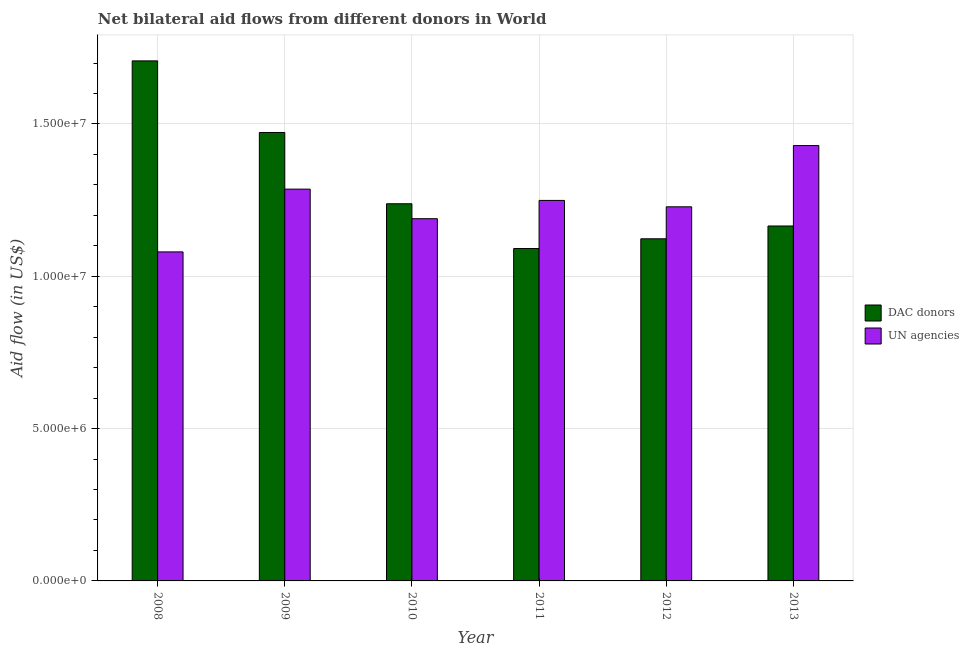How many groups of bars are there?
Offer a terse response. 6. Are the number of bars per tick equal to the number of legend labels?
Make the answer very short. Yes. Are the number of bars on each tick of the X-axis equal?
Offer a terse response. Yes. How many bars are there on the 5th tick from the left?
Offer a very short reply. 2. What is the label of the 3rd group of bars from the left?
Your answer should be very brief. 2010. In how many cases, is the number of bars for a given year not equal to the number of legend labels?
Ensure brevity in your answer.  0. What is the aid flow from dac donors in 2010?
Keep it short and to the point. 1.24e+07. Across all years, what is the maximum aid flow from un agencies?
Keep it short and to the point. 1.43e+07. Across all years, what is the minimum aid flow from un agencies?
Provide a succinct answer. 1.08e+07. What is the total aid flow from dac donors in the graph?
Make the answer very short. 7.80e+07. What is the difference between the aid flow from un agencies in 2009 and that in 2012?
Your response must be concise. 5.80e+05. What is the difference between the aid flow from dac donors in 2011 and the aid flow from un agencies in 2009?
Your answer should be compact. -3.81e+06. What is the average aid flow from dac donors per year?
Your response must be concise. 1.30e+07. What is the ratio of the aid flow from un agencies in 2009 to that in 2013?
Your response must be concise. 0.9. Is the aid flow from dac donors in 2009 less than that in 2012?
Your answer should be compact. No. Is the difference between the aid flow from un agencies in 2008 and 2013 greater than the difference between the aid flow from dac donors in 2008 and 2013?
Provide a succinct answer. No. What is the difference between the highest and the second highest aid flow from dac donors?
Give a very brief answer. 2.35e+06. What is the difference between the highest and the lowest aid flow from dac donors?
Your answer should be very brief. 6.16e+06. In how many years, is the aid flow from un agencies greater than the average aid flow from un agencies taken over all years?
Provide a short and direct response. 3. What does the 2nd bar from the left in 2009 represents?
Offer a very short reply. UN agencies. What does the 2nd bar from the right in 2010 represents?
Offer a terse response. DAC donors. Are all the bars in the graph horizontal?
Provide a succinct answer. No. What is the difference between two consecutive major ticks on the Y-axis?
Your response must be concise. 5.00e+06. Are the values on the major ticks of Y-axis written in scientific E-notation?
Provide a succinct answer. Yes. Does the graph contain grids?
Ensure brevity in your answer.  Yes. Where does the legend appear in the graph?
Offer a very short reply. Center right. What is the title of the graph?
Give a very brief answer. Net bilateral aid flows from different donors in World. What is the label or title of the Y-axis?
Offer a very short reply. Aid flow (in US$). What is the Aid flow (in US$) of DAC donors in 2008?
Make the answer very short. 1.71e+07. What is the Aid flow (in US$) of UN agencies in 2008?
Offer a very short reply. 1.08e+07. What is the Aid flow (in US$) in DAC donors in 2009?
Make the answer very short. 1.47e+07. What is the Aid flow (in US$) in UN agencies in 2009?
Offer a terse response. 1.29e+07. What is the Aid flow (in US$) of DAC donors in 2010?
Ensure brevity in your answer.  1.24e+07. What is the Aid flow (in US$) in UN agencies in 2010?
Provide a succinct answer. 1.19e+07. What is the Aid flow (in US$) of DAC donors in 2011?
Your response must be concise. 1.09e+07. What is the Aid flow (in US$) of UN agencies in 2011?
Your answer should be very brief. 1.25e+07. What is the Aid flow (in US$) of DAC donors in 2012?
Give a very brief answer. 1.12e+07. What is the Aid flow (in US$) of UN agencies in 2012?
Make the answer very short. 1.23e+07. What is the Aid flow (in US$) in DAC donors in 2013?
Your response must be concise. 1.16e+07. What is the Aid flow (in US$) of UN agencies in 2013?
Offer a terse response. 1.43e+07. Across all years, what is the maximum Aid flow (in US$) of DAC donors?
Give a very brief answer. 1.71e+07. Across all years, what is the maximum Aid flow (in US$) of UN agencies?
Ensure brevity in your answer.  1.43e+07. Across all years, what is the minimum Aid flow (in US$) of DAC donors?
Your answer should be compact. 1.09e+07. Across all years, what is the minimum Aid flow (in US$) in UN agencies?
Keep it short and to the point. 1.08e+07. What is the total Aid flow (in US$) in DAC donors in the graph?
Offer a terse response. 7.80e+07. What is the total Aid flow (in US$) in UN agencies in the graph?
Provide a succinct answer. 7.46e+07. What is the difference between the Aid flow (in US$) of DAC donors in 2008 and that in 2009?
Ensure brevity in your answer.  2.35e+06. What is the difference between the Aid flow (in US$) of UN agencies in 2008 and that in 2009?
Provide a succinct answer. -2.06e+06. What is the difference between the Aid flow (in US$) in DAC donors in 2008 and that in 2010?
Your answer should be compact. 4.69e+06. What is the difference between the Aid flow (in US$) in UN agencies in 2008 and that in 2010?
Keep it short and to the point. -1.09e+06. What is the difference between the Aid flow (in US$) of DAC donors in 2008 and that in 2011?
Make the answer very short. 6.16e+06. What is the difference between the Aid flow (in US$) in UN agencies in 2008 and that in 2011?
Provide a short and direct response. -1.69e+06. What is the difference between the Aid flow (in US$) in DAC donors in 2008 and that in 2012?
Provide a short and direct response. 5.84e+06. What is the difference between the Aid flow (in US$) of UN agencies in 2008 and that in 2012?
Your answer should be very brief. -1.48e+06. What is the difference between the Aid flow (in US$) of DAC donors in 2008 and that in 2013?
Provide a short and direct response. 5.42e+06. What is the difference between the Aid flow (in US$) of UN agencies in 2008 and that in 2013?
Offer a terse response. -3.49e+06. What is the difference between the Aid flow (in US$) in DAC donors in 2009 and that in 2010?
Your answer should be very brief. 2.34e+06. What is the difference between the Aid flow (in US$) of UN agencies in 2009 and that in 2010?
Make the answer very short. 9.70e+05. What is the difference between the Aid flow (in US$) in DAC donors in 2009 and that in 2011?
Keep it short and to the point. 3.81e+06. What is the difference between the Aid flow (in US$) in UN agencies in 2009 and that in 2011?
Your response must be concise. 3.70e+05. What is the difference between the Aid flow (in US$) in DAC donors in 2009 and that in 2012?
Ensure brevity in your answer.  3.49e+06. What is the difference between the Aid flow (in US$) in UN agencies in 2009 and that in 2012?
Offer a terse response. 5.80e+05. What is the difference between the Aid flow (in US$) in DAC donors in 2009 and that in 2013?
Offer a very short reply. 3.07e+06. What is the difference between the Aid flow (in US$) of UN agencies in 2009 and that in 2013?
Your answer should be very brief. -1.43e+06. What is the difference between the Aid flow (in US$) in DAC donors in 2010 and that in 2011?
Your answer should be very brief. 1.47e+06. What is the difference between the Aid flow (in US$) of UN agencies in 2010 and that in 2011?
Offer a very short reply. -6.00e+05. What is the difference between the Aid flow (in US$) in DAC donors in 2010 and that in 2012?
Your response must be concise. 1.15e+06. What is the difference between the Aid flow (in US$) of UN agencies in 2010 and that in 2012?
Your response must be concise. -3.90e+05. What is the difference between the Aid flow (in US$) in DAC donors in 2010 and that in 2013?
Make the answer very short. 7.30e+05. What is the difference between the Aid flow (in US$) in UN agencies in 2010 and that in 2013?
Your response must be concise. -2.40e+06. What is the difference between the Aid flow (in US$) of DAC donors in 2011 and that in 2012?
Provide a succinct answer. -3.20e+05. What is the difference between the Aid flow (in US$) of UN agencies in 2011 and that in 2012?
Offer a terse response. 2.10e+05. What is the difference between the Aid flow (in US$) in DAC donors in 2011 and that in 2013?
Make the answer very short. -7.40e+05. What is the difference between the Aid flow (in US$) in UN agencies in 2011 and that in 2013?
Your answer should be very brief. -1.80e+06. What is the difference between the Aid flow (in US$) in DAC donors in 2012 and that in 2013?
Your answer should be compact. -4.20e+05. What is the difference between the Aid flow (in US$) of UN agencies in 2012 and that in 2013?
Make the answer very short. -2.01e+06. What is the difference between the Aid flow (in US$) in DAC donors in 2008 and the Aid flow (in US$) in UN agencies in 2009?
Provide a short and direct response. 4.21e+06. What is the difference between the Aid flow (in US$) in DAC donors in 2008 and the Aid flow (in US$) in UN agencies in 2010?
Make the answer very short. 5.18e+06. What is the difference between the Aid flow (in US$) of DAC donors in 2008 and the Aid flow (in US$) of UN agencies in 2011?
Keep it short and to the point. 4.58e+06. What is the difference between the Aid flow (in US$) of DAC donors in 2008 and the Aid flow (in US$) of UN agencies in 2012?
Provide a succinct answer. 4.79e+06. What is the difference between the Aid flow (in US$) in DAC donors in 2008 and the Aid flow (in US$) in UN agencies in 2013?
Your answer should be compact. 2.78e+06. What is the difference between the Aid flow (in US$) of DAC donors in 2009 and the Aid flow (in US$) of UN agencies in 2010?
Ensure brevity in your answer.  2.83e+06. What is the difference between the Aid flow (in US$) in DAC donors in 2009 and the Aid flow (in US$) in UN agencies in 2011?
Your answer should be compact. 2.23e+06. What is the difference between the Aid flow (in US$) of DAC donors in 2009 and the Aid flow (in US$) of UN agencies in 2012?
Your response must be concise. 2.44e+06. What is the difference between the Aid flow (in US$) in DAC donors in 2009 and the Aid flow (in US$) in UN agencies in 2013?
Keep it short and to the point. 4.30e+05. What is the difference between the Aid flow (in US$) of DAC donors in 2010 and the Aid flow (in US$) of UN agencies in 2012?
Your answer should be very brief. 1.00e+05. What is the difference between the Aid flow (in US$) of DAC donors in 2010 and the Aid flow (in US$) of UN agencies in 2013?
Keep it short and to the point. -1.91e+06. What is the difference between the Aid flow (in US$) in DAC donors in 2011 and the Aid flow (in US$) in UN agencies in 2012?
Give a very brief answer. -1.37e+06. What is the difference between the Aid flow (in US$) in DAC donors in 2011 and the Aid flow (in US$) in UN agencies in 2013?
Offer a very short reply. -3.38e+06. What is the difference between the Aid flow (in US$) in DAC donors in 2012 and the Aid flow (in US$) in UN agencies in 2013?
Provide a succinct answer. -3.06e+06. What is the average Aid flow (in US$) in DAC donors per year?
Your answer should be compact. 1.30e+07. What is the average Aid flow (in US$) of UN agencies per year?
Keep it short and to the point. 1.24e+07. In the year 2008, what is the difference between the Aid flow (in US$) in DAC donors and Aid flow (in US$) in UN agencies?
Keep it short and to the point. 6.27e+06. In the year 2009, what is the difference between the Aid flow (in US$) in DAC donors and Aid flow (in US$) in UN agencies?
Offer a very short reply. 1.86e+06. In the year 2010, what is the difference between the Aid flow (in US$) of DAC donors and Aid flow (in US$) of UN agencies?
Give a very brief answer. 4.90e+05. In the year 2011, what is the difference between the Aid flow (in US$) in DAC donors and Aid flow (in US$) in UN agencies?
Offer a terse response. -1.58e+06. In the year 2012, what is the difference between the Aid flow (in US$) of DAC donors and Aid flow (in US$) of UN agencies?
Offer a terse response. -1.05e+06. In the year 2013, what is the difference between the Aid flow (in US$) of DAC donors and Aid flow (in US$) of UN agencies?
Provide a succinct answer. -2.64e+06. What is the ratio of the Aid flow (in US$) in DAC donors in 2008 to that in 2009?
Keep it short and to the point. 1.16. What is the ratio of the Aid flow (in US$) in UN agencies in 2008 to that in 2009?
Your response must be concise. 0.84. What is the ratio of the Aid flow (in US$) in DAC donors in 2008 to that in 2010?
Give a very brief answer. 1.38. What is the ratio of the Aid flow (in US$) of UN agencies in 2008 to that in 2010?
Give a very brief answer. 0.91. What is the ratio of the Aid flow (in US$) in DAC donors in 2008 to that in 2011?
Provide a short and direct response. 1.56. What is the ratio of the Aid flow (in US$) in UN agencies in 2008 to that in 2011?
Offer a very short reply. 0.86. What is the ratio of the Aid flow (in US$) in DAC donors in 2008 to that in 2012?
Offer a very short reply. 1.52. What is the ratio of the Aid flow (in US$) of UN agencies in 2008 to that in 2012?
Provide a succinct answer. 0.88. What is the ratio of the Aid flow (in US$) in DAC donors in 2008 to that in 2013?
Provide a succinct answer. 1.47. What is the ratio of the Aid flow (in US$) of UN agencies in 2008 to that in 2013?
Provide a succinct answer. 0.76. What is the ratio of the Aid flow (in US$) in DAC donors in 2009 to that in 2010?
Ensure brevity in your answer.  1.19. What is the ratio of the Aid flow (in US$) of UN agencies in 2009 to that in 2010?
Ensure brevity in your answer.  1.08. What is the ratio of the Aid flow (in US$) in DAC donors in 2009 to that in 2011?
Make the answer very short. 1.35. What is the ratio of the Aid flow (in US$) in UN agencies in 2009 to that in 2011?
Ensure brevity in your answer.  1.03. What is the ratio of the Aid flow (in US$) in DAC donors in 2009 to that in 2012?
Give a very brief answer. 1.31. What is the ratio of the Aid flow (in US$) in UN agencies in 2009 to that in 2012?
Your answer should be very brief. 1.05. What is the ratio of the Aid flow (in US$) of DAC donors in 2009 to that in 2013?
Offer a terse response. 1.26. What is the ratio of the Aid flow (in US$) of UN agencies in 2009 to that in 2013?
Give a very brief answer. 0.9. What is the ratio of the Aid flow (in US$) of DAC donors in 2010 to that in 2011?
Offer a very short reply. 1.13. What is the ratio of the Aid flow (in US$) of DAC donors in 2010 to that in 2012?
Ensure brevity in your answer.  1.1. What is the ratio of the Aid flow (in US$) in UN agencies in 2010 to that in 2012?
Provide a succinct answer. 0.97. What is the ratio of the Aid flow (in US$) of DAC donors in 2010 to that in 2013?
Keep it short and to the point. 1.06. What is the ratio of the Aid flow (in US$) in UN agencies in 2010 to that in 2013?
Your response must be concise. 0.83. What is the ratio of the Aid flow (in US$) of DAC donors in 2011 to that in 2012?
Offer a terse response. 0.97. What is the ratio of the Aid flow (in US$) in UN agencies in 2011 to that in 2012?
Make the answer very short. 1.02. What is the ratio of the Aid flow (in US$) in DAC donors in 2011 to that in 2013?
Keep it short and to the point. 0.94. What is the ratio of the Aid flow (in US$) in UN agencies in 2011 to that in 2013?
Make the answer very short. 0.87. What is the ratio of the Aid flow (in US$) of DAC donors in 2012 to that in 2013?
Ensure brevity in your answer.  0.96. What is the ratio of the Aid flow (in US$) of UN agencies in 2012 to that in 2013?
Offer a very short reply. 0.86. What is the difference between the highest and the second highest Aid flow (in US$) of DAC donors?
Keep it short and to the point. 2.35e+06. What is the difference between the highest and the second highest Aid flow (in US$) in UN agencies?
Offer a very short reply. 1.43e+06. What is the difference between the highest and the lowest Aid flow (in US$) of DAC donors?
Your answer should be compact. 6.16e+06. What is the difference between the highest and the lowest Aid flow (in US$) in UN agencies?
Your answer should be very brief. 3.49e+06. 